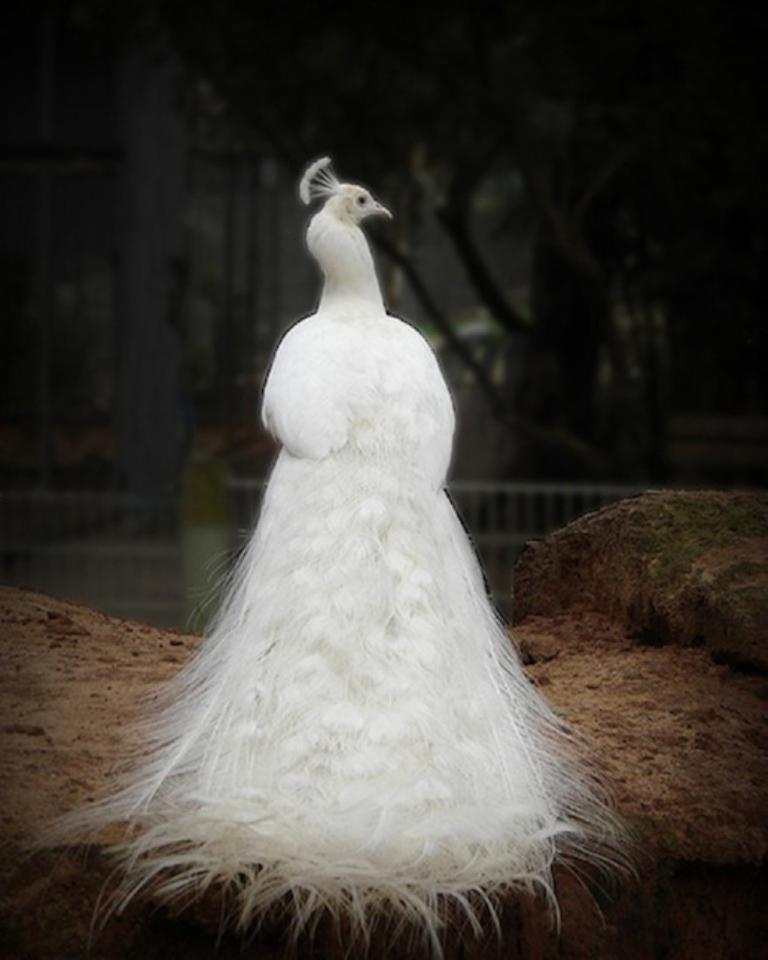What type of bird is the main subject of the picture? There is a white peacock in the picture. Can you describe the background of the image? The background of the image is blurred. What type of request can be seen in the image? There is no request present in the image; it features a white peacock and a blurred background. What type of tool is being used to pickle the peacock in the image? There is no tool or pickling process depicted in the image; it features a white peacock and a blurred background. 